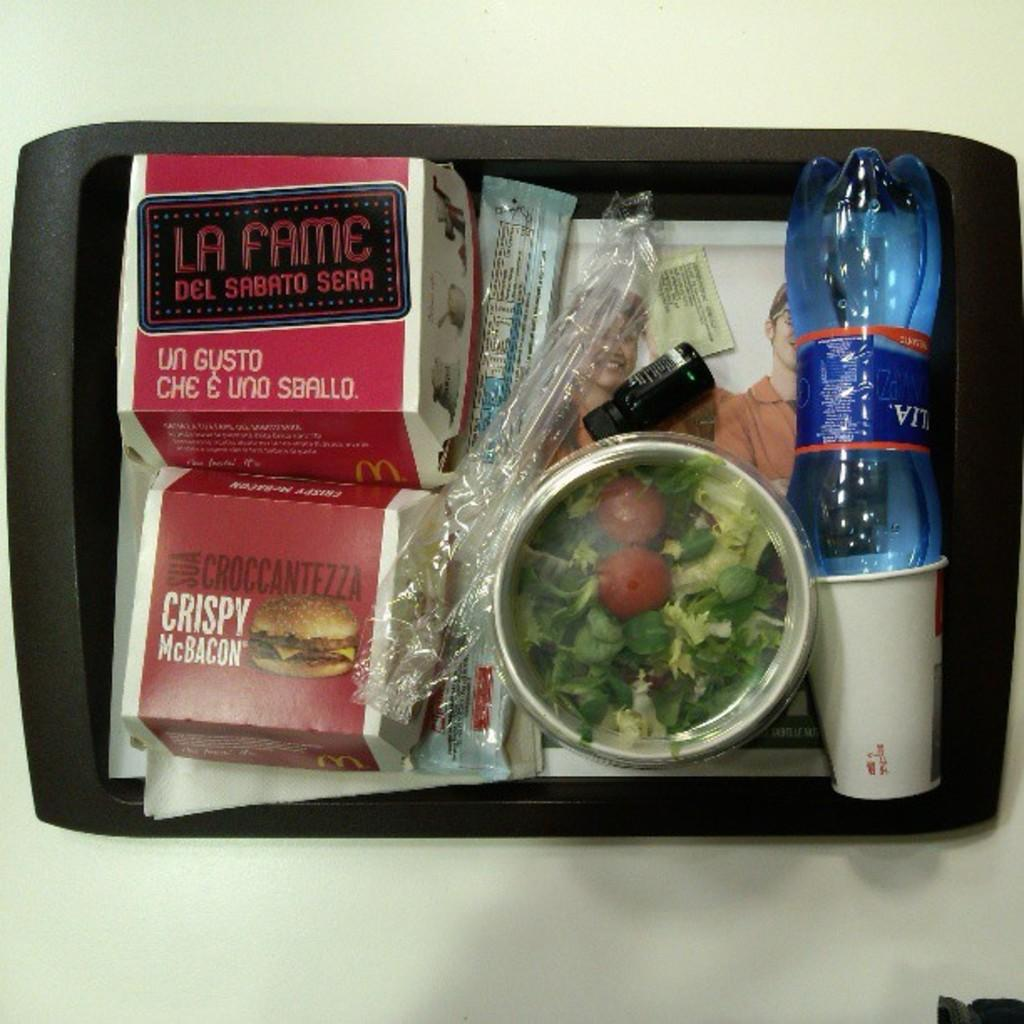<image>
Write a terse but informative summary of the picture. A food tray contains many items, including a Crispy McBacon. 